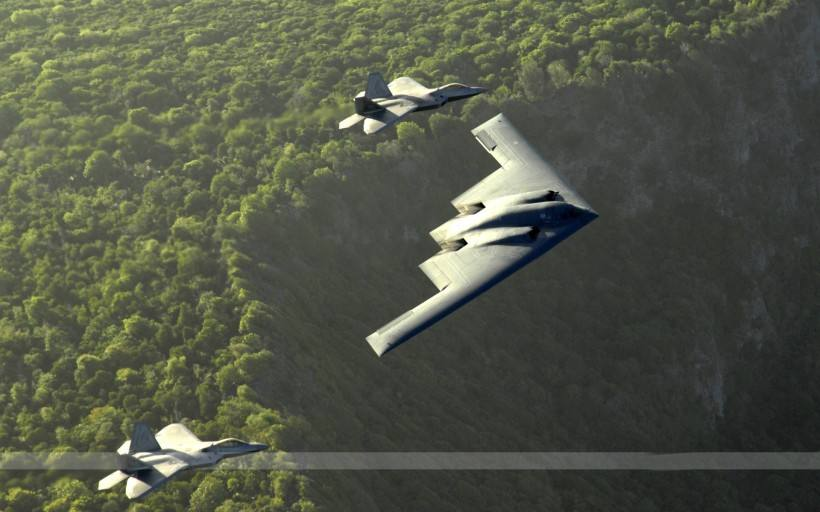The aeroplanes appear to be military; can you infer their possible mission from this formation? While the exact mission cannot be determined from this image alone, the tight formation suggests a strategic display of force or a practice session for tactical maneuvers. Such formations are frequently used to exhibit the aeroplanes' agility and the pilots' expertise, possibly in preparation for ceremonial events or to maintain readiness for actual combat scenarios. 